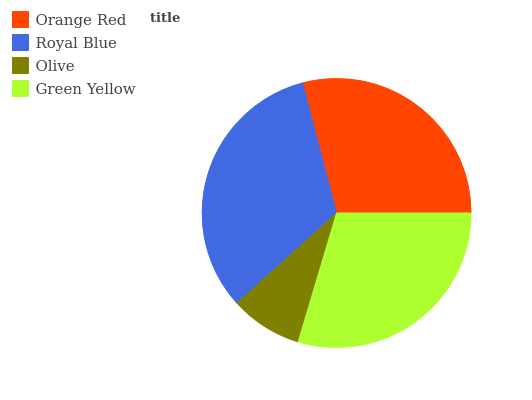Is Olive the minimum?
Answer yes or no. Yes. Is Royal Blue the maximum?
Answer yes or no. Yes. Is Royal Blue the minimum?
Answer yes or no. No. Is Olive the maximum?
Answer yes or no. No. Is Royal Blue greater than Olive?
Answer yes or no. Yes. Is Olive less than Royal Blue?
Answer yes or no. Yes. Is Olive greater than Royal Blue?
Answer yes or no. No. Is Royal Blue less than Olive?
Answer yes or no. No. Is Green Yellow the high median?
Answer yes or no. Yes. Is Orange Red the low median?
Answer yes or no. Yes. Is Orange Red the high median?
Answer yes or no. No. Is Green Yellow the low median?
Answer yes or no. No. 